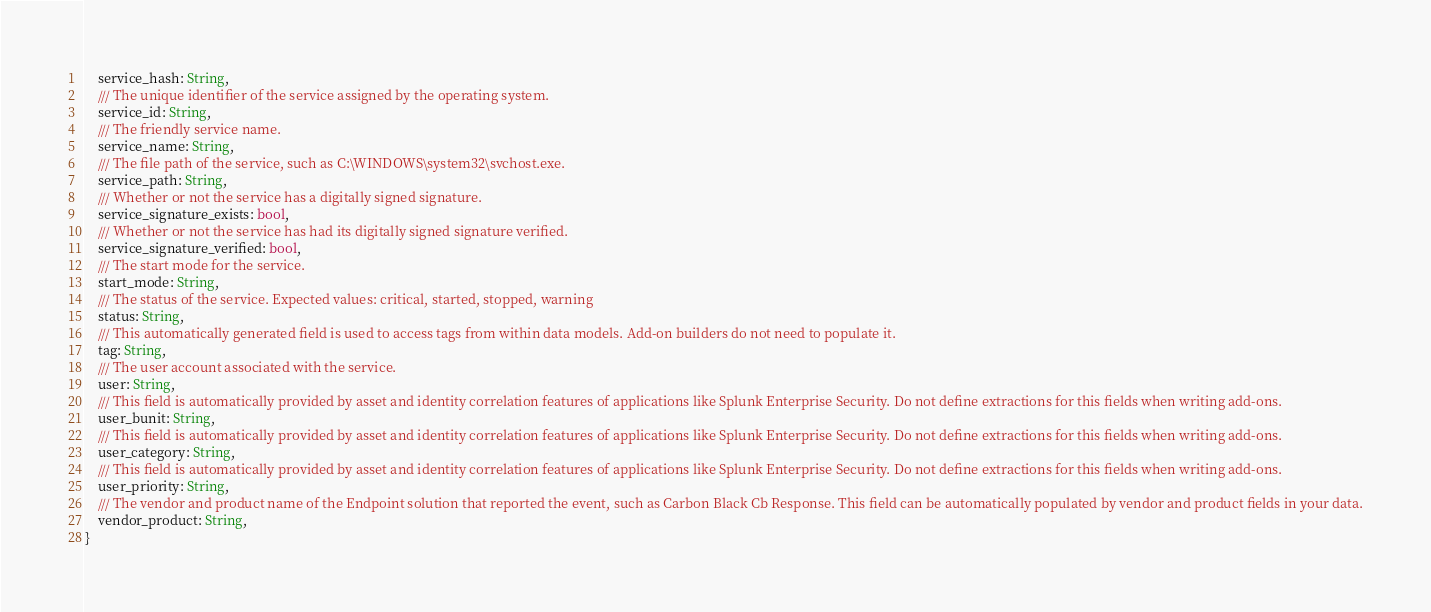Convert code to text. <code><loc_0><loc_0><loc_500><loc_500><_Rust_>	service_hash: String,
	/// The unique identifier of the service assigned by the operating system.
	service_id: String,
	/// The friendly service name.
	service_name: String,
	/// The file path of the service, such as C:\WINDOWS\system32\svchost.exe.
	service_path: String,
	/// Whether or not the service has a digitally signed signature.
	service_signature_exists: bool,
	/// Whether or not the service has had its digitally signed signature verified.
	service_signature_verified: bool,
	/// The start mode for the service.
	start_mode: String,
	/// The status of the service. Expected values: critical, started, stopped, warning
	status: String,
	/// This automatically generated field is used to access tags from within data models. Add-on builders do not need to populate it.
	tag: String,
	/// The user account associated with the service.
	user: String,
	/// This field is automatically provided by asset and identity correlation features of applications like Splunk Enterprise Security. Do not define extractions for this fields when writing add-ons.
	user_bunit: String,
	/// This field is automatically provided by asset and identity correlation features of applications like Splunk Enterprise Security. Do not define extractions for this fields when writing add-ons.
	user_category: String,
	/// This field is automatically provided by asset and identity correlation features of applications like Splunk Enterprise Security. Do not define extractions for this fields when writing add-ons.
	user_priority: String,
	/// The vendor and product name of the Endpoint solution that reported the event, such as Carbon Black Cb Response. This field can be automatically populated by vendor and product fields in your data.
	vendor_product: String,
}</code> 